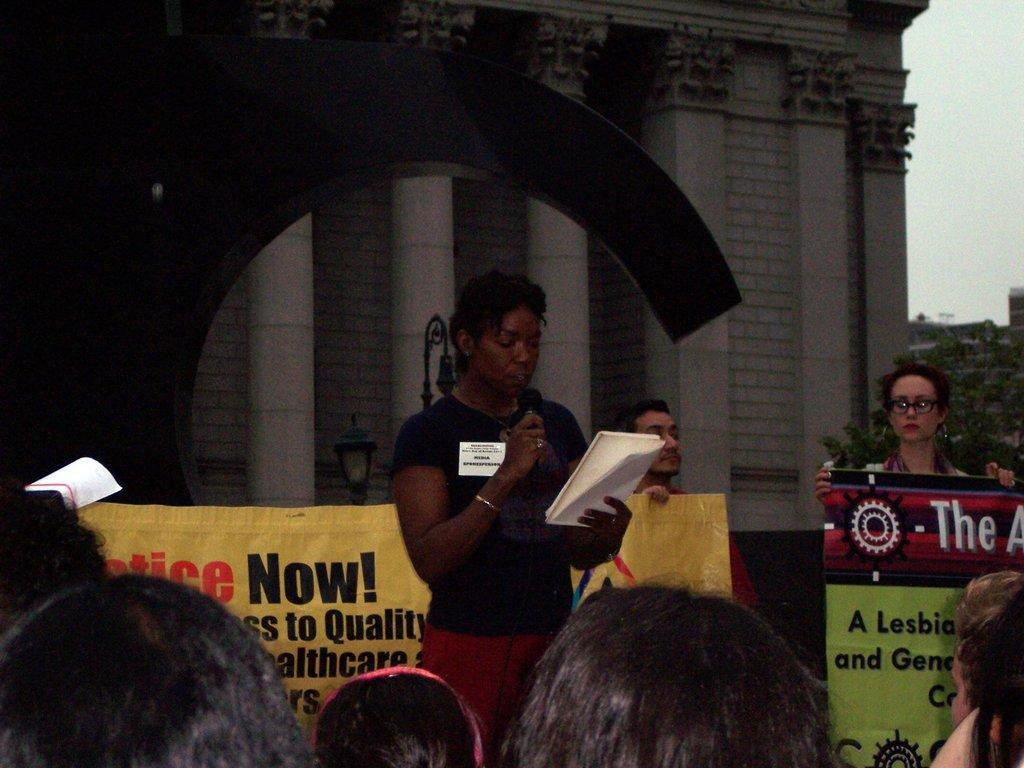In one or two sentences, can you explain what this image depicts? In this picture we can see a group of people were two are holding banners with their hands and a woman holding a mic, book with her hands and at the back of her we can see a building with pillars, trees and in the background we can see the sky. 